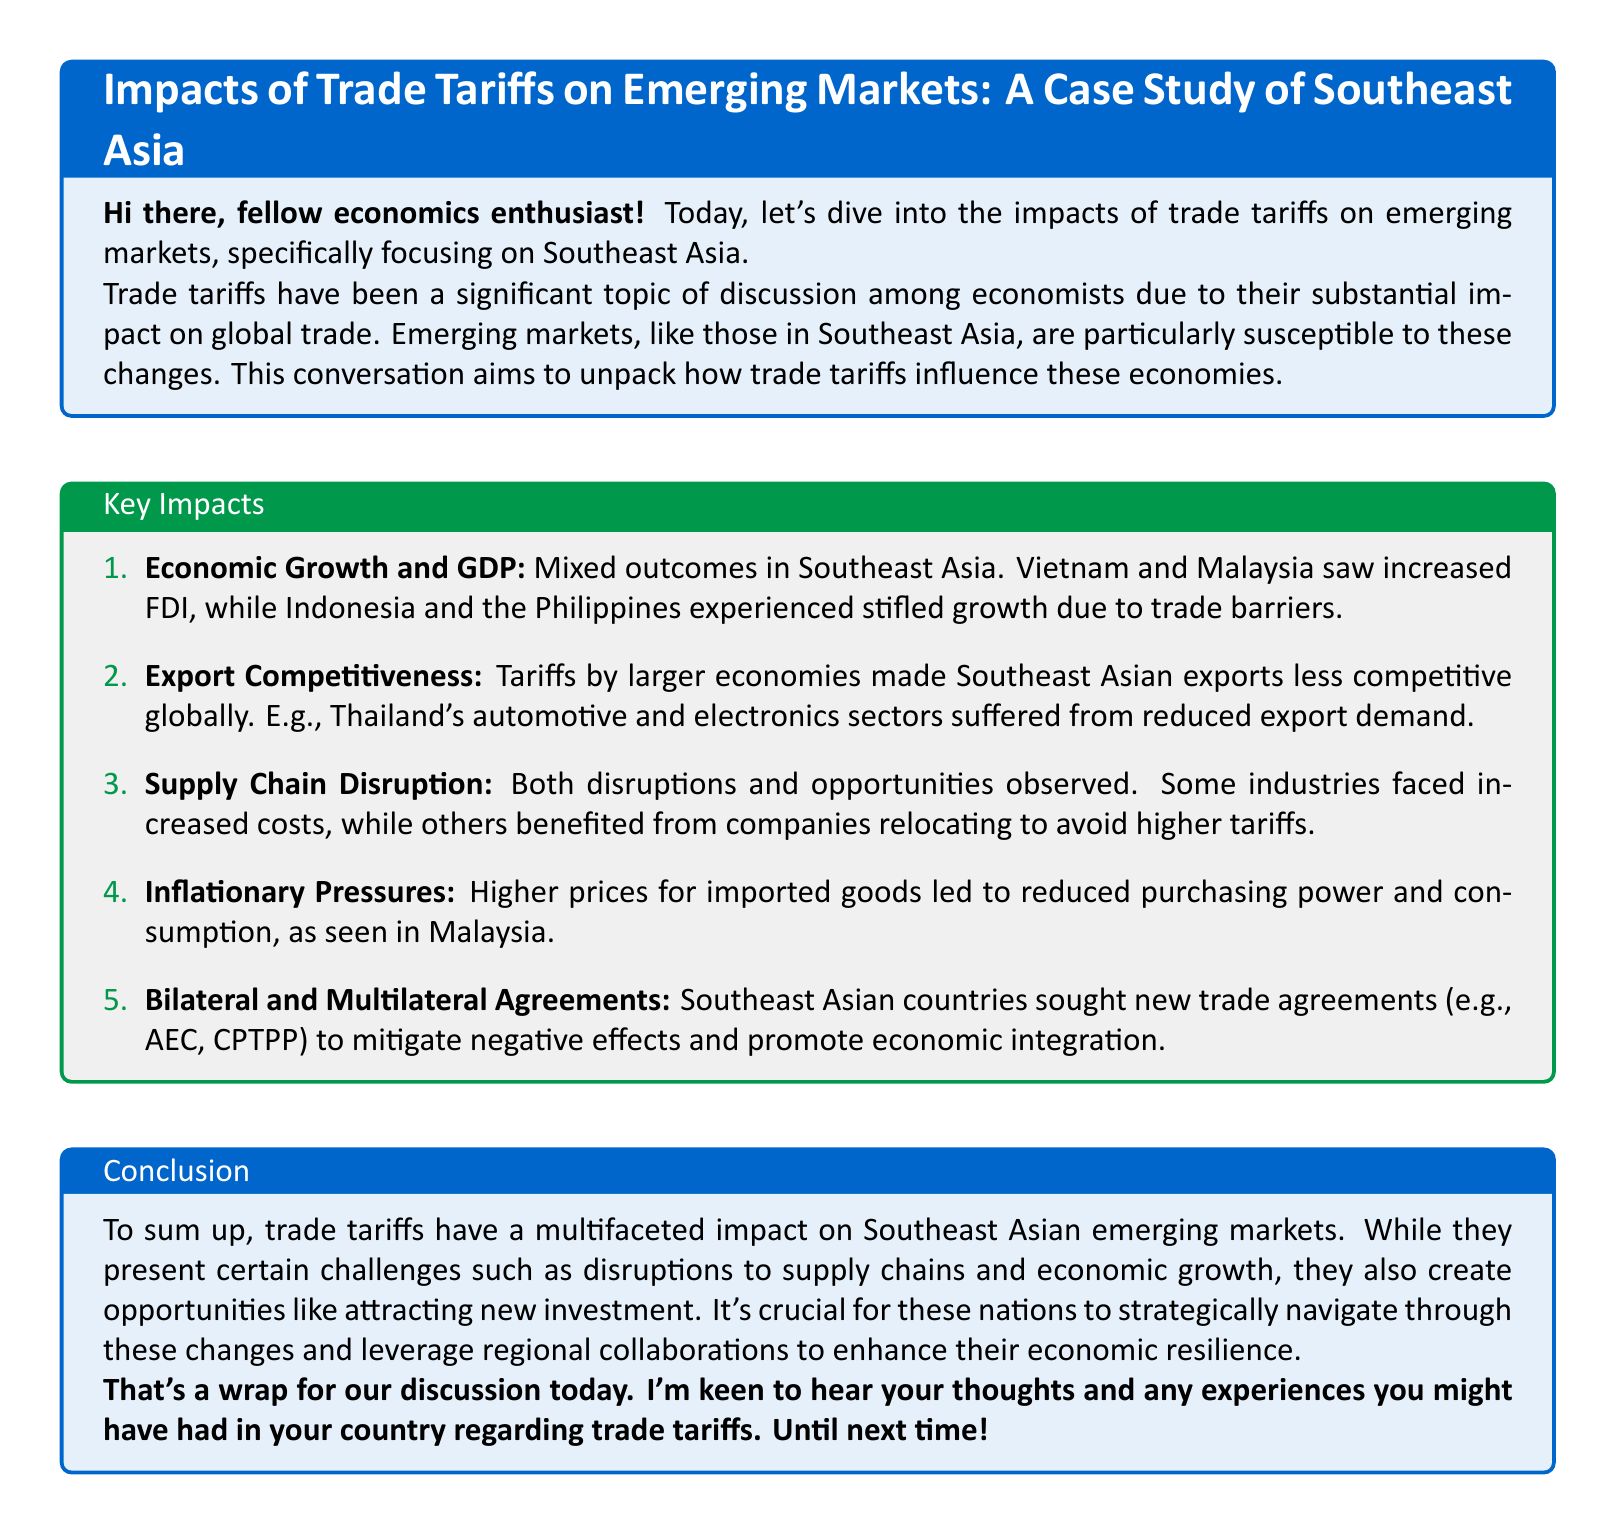What are the mixed outcomes in Southeast Asia? The mixed outcomes refer to varied responses in economic growth across countries, with Vietnam and Malaysia seeing increased FDI, while Indonesia and the Philippines experienced stifled growth.
Answer: Mixed outcomes Which Southeast Asian country suffered in the automotive and electronics sectors? Thailand's automotive and electronics sectors suffered from reduced export demand due to tariffs imposed by larger economies.
Answer: Thailand What is one economic effect of tariffs on imported goods mentioned in the document? Higher prices for imported goods led to reduced purchasing power and consumption.
Answer: Reduced purchasing power What are the trade agreements mentioned that Southeast Asian countries sought? Countries sought new trade agreements such as AEC and CPTPP to mitigate negative effects and promote economic integration.
Answer: AEC, CPTPP What should Southeast Asian nations do to enhance their economic resilience? They should strategically navigate through changes and leverage regional collaborations.
Answer: Leverage regional collaborations 